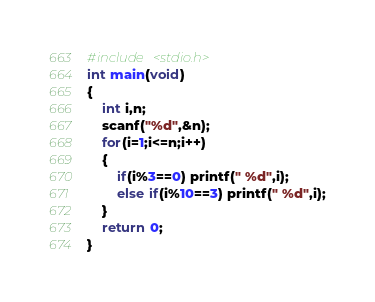<code> <loc_0><loc_0><loc_500><loc_500><_C_>#include <stdio.h>
int main(void)
{
    int i,n;
    scanf("%d",&n);
    for(i=1;i<=n;i++)
    {
        if(i%3==0) printf(" %d",i);
        else if(i%10==3) printf(" %d",i);
    }
    return 0;
}
</code> 